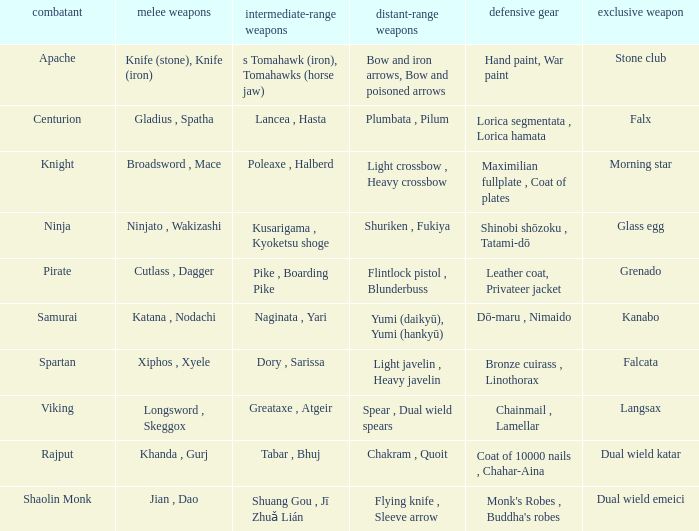If the special weapon is the Grenado, what is the armor? Leather coat, Privateer jacket. 